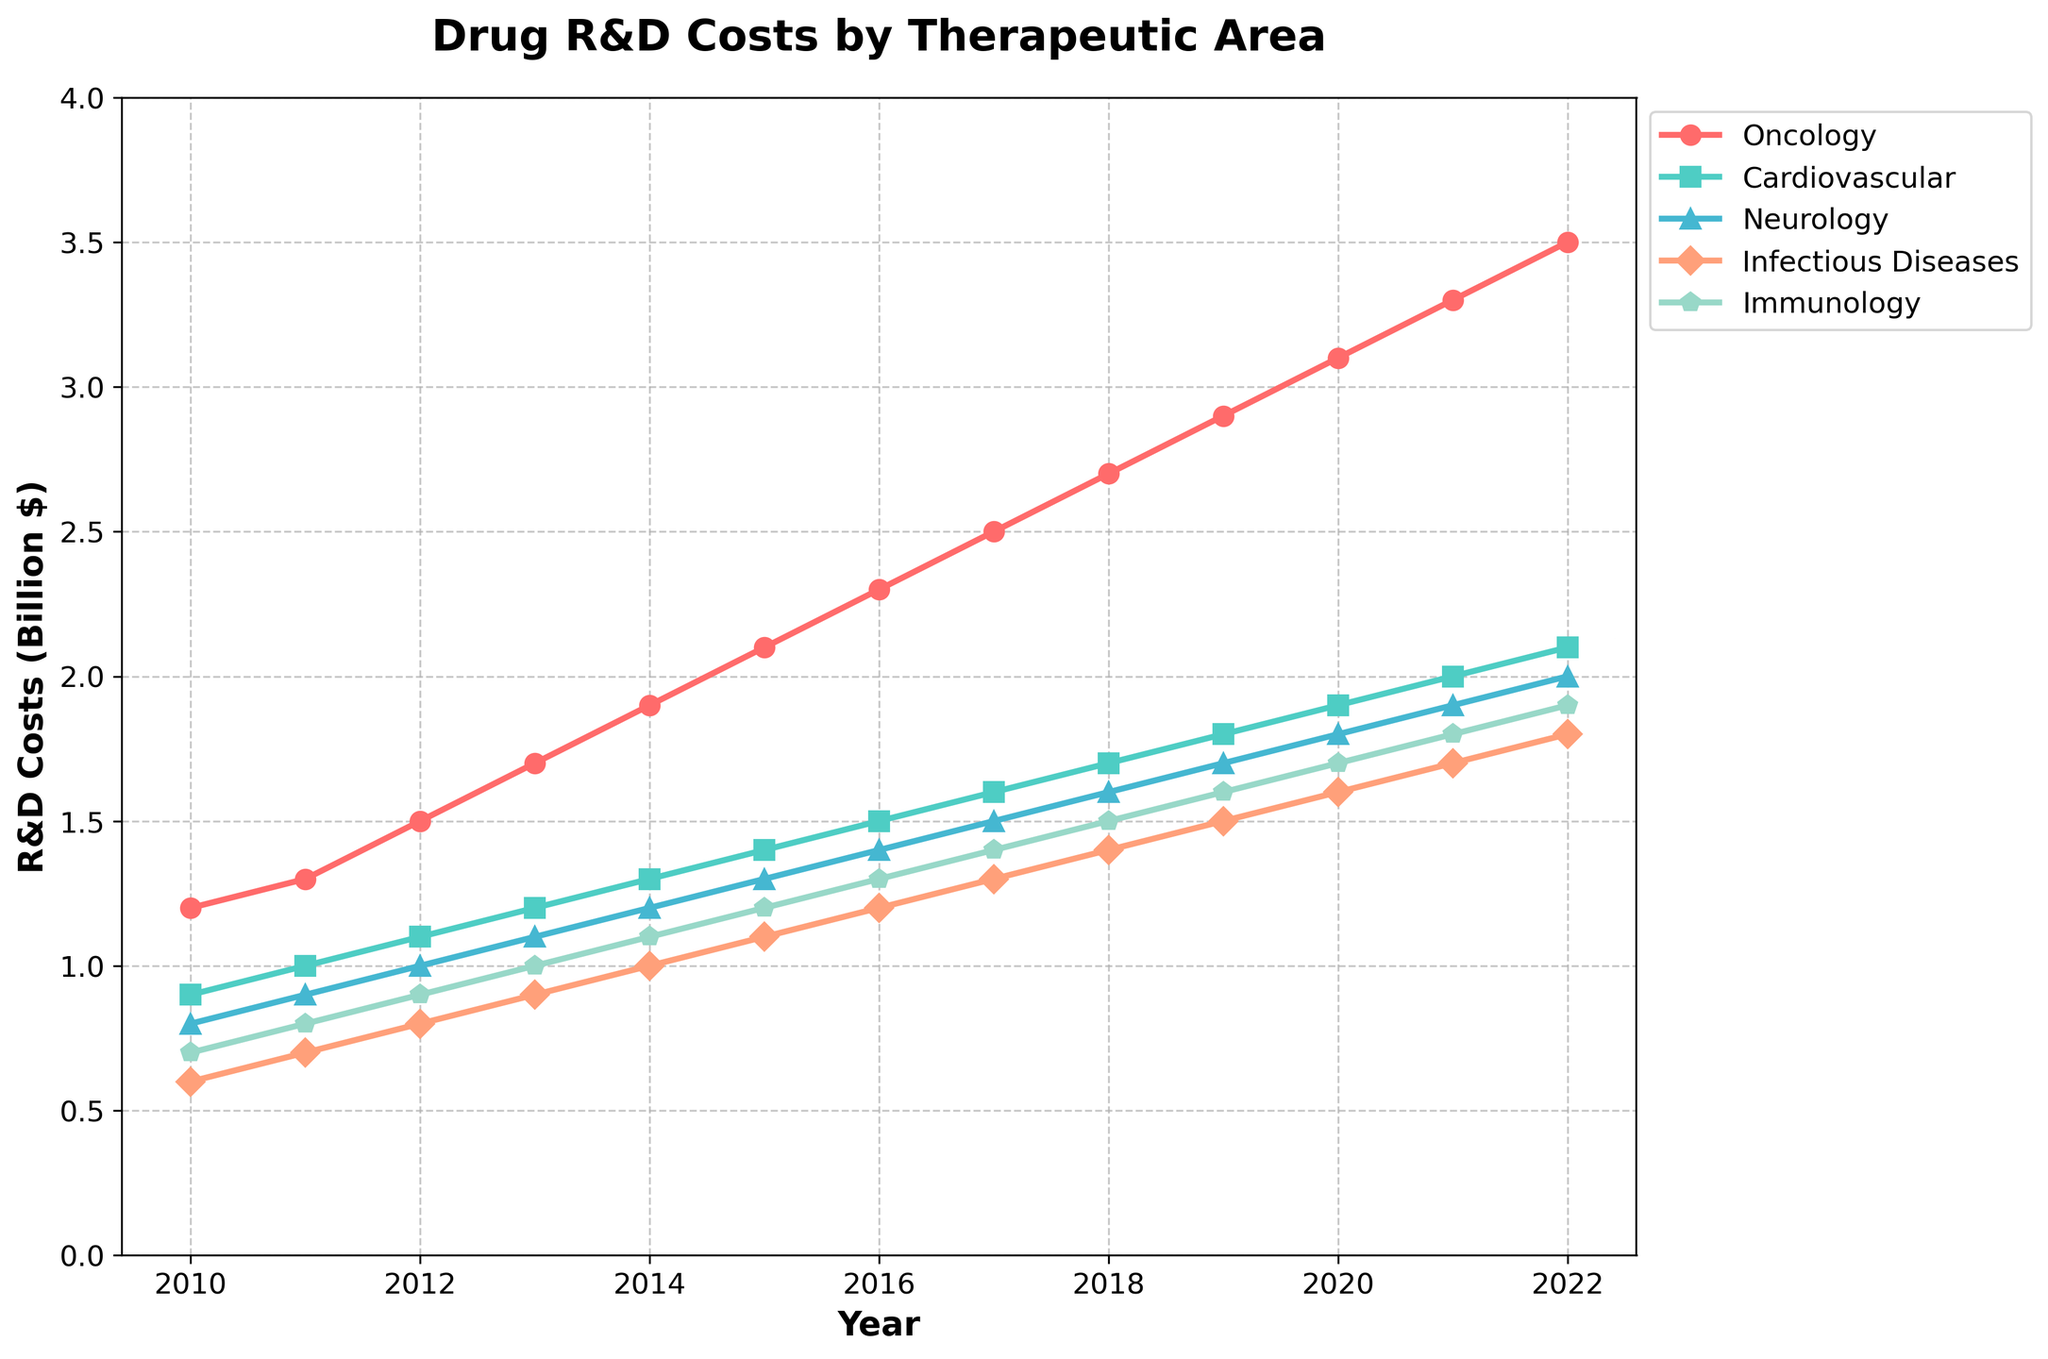What is the trend in Oncology R&D costs from 2010 to 2022? To determine the trend, observe the increasing values for Oncology R&D costs over the years. The values start at 1.2 in 2010 and rise to 3.5 in 2022. The increase every year shows an upward trend.
Answer: Increasing trend Which therapeutic area had the highest R&D cost in 2022? Look at the endpoints of the lines for 2022 and compare the R&D costs. Oncology has the highest value, reaching 3.5 billion dollars.
Answer: Oncology Comparing Immunology and Cardiovascular R&D costs in 2015, which was higher and by how much? Immunology has a value of 1.2 and Cardiovascular has 1.4 in 2015. Subtracting Immunology from Cardiovascular gives 1.4 - 1.2 = 0.2.
Answer: Cardiovascular, 0.2 billion dollars What was the average R&D cost for Neurology between 2010 and 2022? Sum the values for Neurology from 2010 to 2022 (0.8 + 0.9 + 1.0 + 1.1 + 1.2 + 1.3 + 1.4 + 1.5 + 1.6 + 1.7 + 1.8 + 1.9 + 2.0). The sum is 18.4. Dividing by the number of years (13) gives 18.4 / 13 ≈ 1.42.
Answer: Approximately 1.42 billion dollars How do the trends for Cardiovascular and Infectious Diseases R&D costs compare over the entire period? By observing both lines, we notice that Cardiovascular increases steadily from 0.9 to 2.1, while Infectious Diseases starts at 0.6 and rises to 1.8. Both show an increasing trend, but Cardiovascular's increase is more moderate compared to the steadier but significant increase in Infectious Diseases.
Answer: Both increasing, Cardiovascular more moderate What is the rate of increase in Oncology R&D costs from 2010 to 2022? The increase over 13 years is 3.5 - 1.2 = 2.3. Dividing by the 12 years interval (2022-2010) gives 2.3 / 12 ≈ 0.192 billion dollars per year.
Answer: Approximately 0.192 billion dollars per year Between which consecutive years did Neurology see the largest increase in R&D costs? Calculate the year-to-year differences for Neurology: 2011-2010: 0.1, 2012-2011: 0.1, 2013-2012: 0.1, 2014-2013: 0.1, 2015-2014: 0.1, 2016-2015: 0.1, 2017-2016: 0.1, 2018-2017: 0.1, 2019-2018: 0.1, 2020-2019: 0.1, 2021-2020: 0.1, 2022-2021: 0.1. All increases are equal (0.1), indicating consistent growth.
Answer: No significant difference, all 0.1 billion dollars What is the cumulative R&D cost for Infectious Diseases from 2010 to 2022? Add up all values for Infectious Diseases: 0.6 + 0.7 + 0.8 + 0.9 + 1.0 + 1.1 + 1.2 + 1.3 + 1.4 + 1.5 + 1.6 + 1.7 + 1.8 = 16.6.
Answer: 16.6 billion dollars Which therapeutic area exhibited the steadiest growth in R&D costs over the period? By observing the slope of each line, Neurology shows the steadiest growth with a consistent increase of 0.1 billion dollars each year.
Answer: Neurology What was the total R&D cost across all therapeutic areas in 2016? Sum the values for each therapeutic area in 2016: 2.3 (Oncology) + 1.5 (Cardiovascular) + 1.4 (Neurology) + 1.2 (Infectious Diseases) + 1.3 (Immunology) = 7.7.
Answer: 7.7 billion dollars 